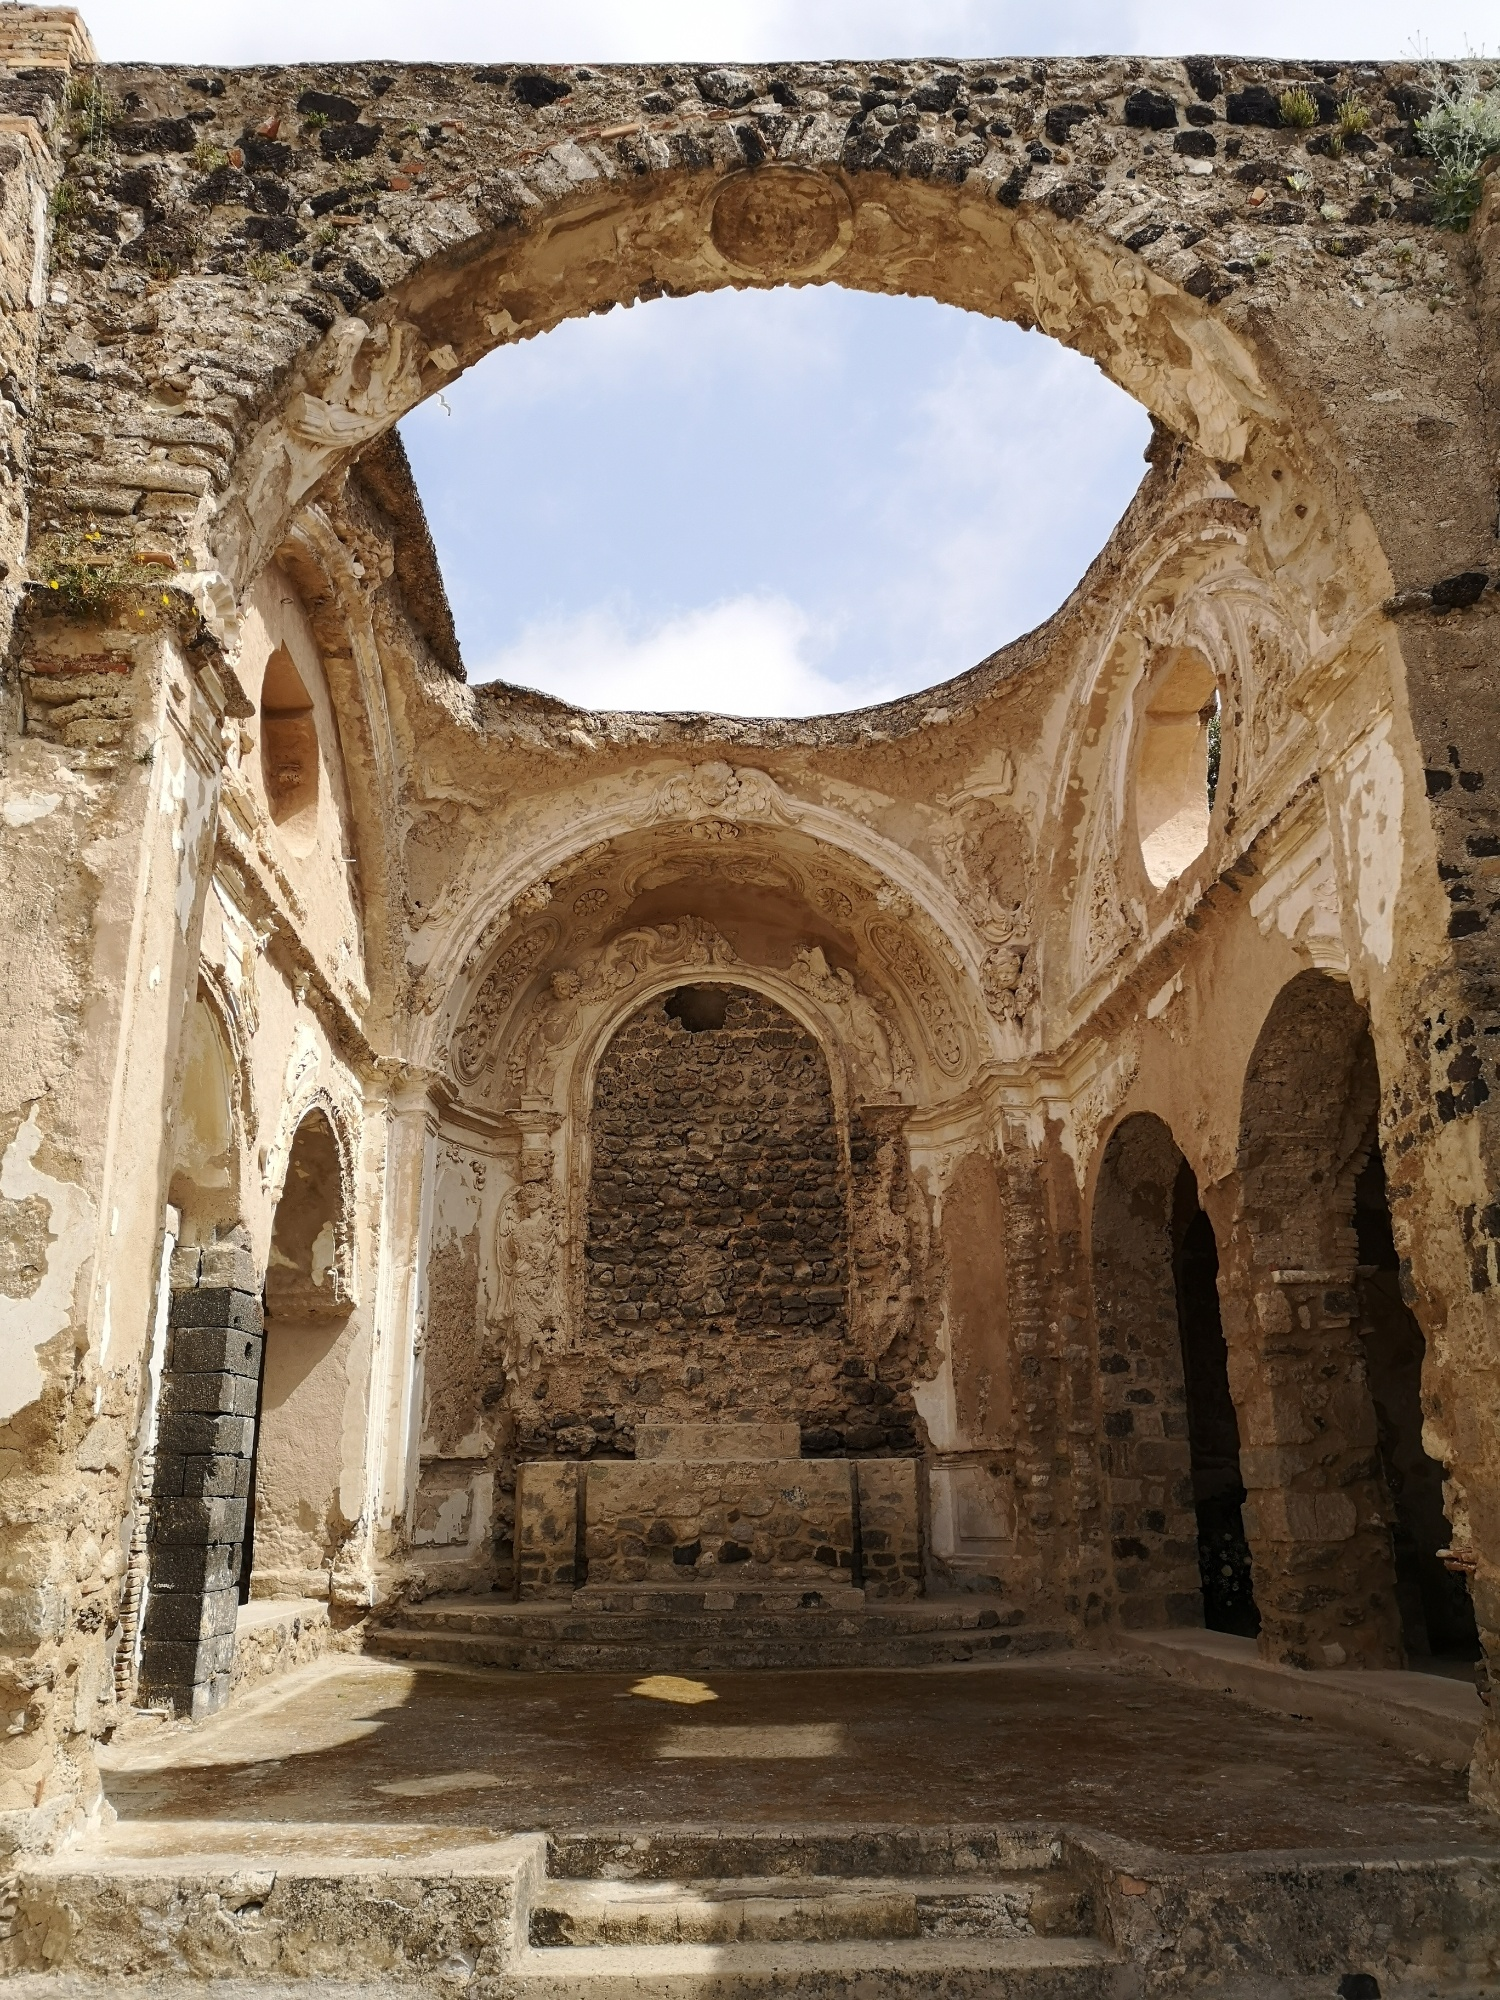What could have caused this structure to fall into ruin? Several factors could contribute to the ruinous state of this structure. Natural elements such as earthquakes, weathering, and erosion play a significant role in the deterioration of ancient buildings. Additionally, human activities like wars, neglect, and abandonment over the centuries might have accelerated the decay. The lack of modern restoration efforts suggests it has been long abandoned, left to the mercy of time and nature. Imagine what the area around this structure might have looked like in its prime. Can you describe it? In its prime, the area around this structure would have been bustling with activity and life. Lush green gardens, meticulously landscaped, might have surrounded the building, providing a serene and peaceful environment for worshippers and visitors. The main pathway leading to the entrance would likely have been paved with stone or cobblestone, lined with ornamental statues or columns. During festivals and religious ceremonies, the surroundings would have been adorned with vibrant decorations, flowers, and banners. People in traditional attire would gather in large numbers, filling the air with chatter, prayers, and the scent of incense. Market stalls might have been set up nearby, selling food, religious artifacts, and other goods to the throngs of visitors. Musicians and performers could be seen entertaining the crowd, making the area a lively and colorful hub of social and religious life. 